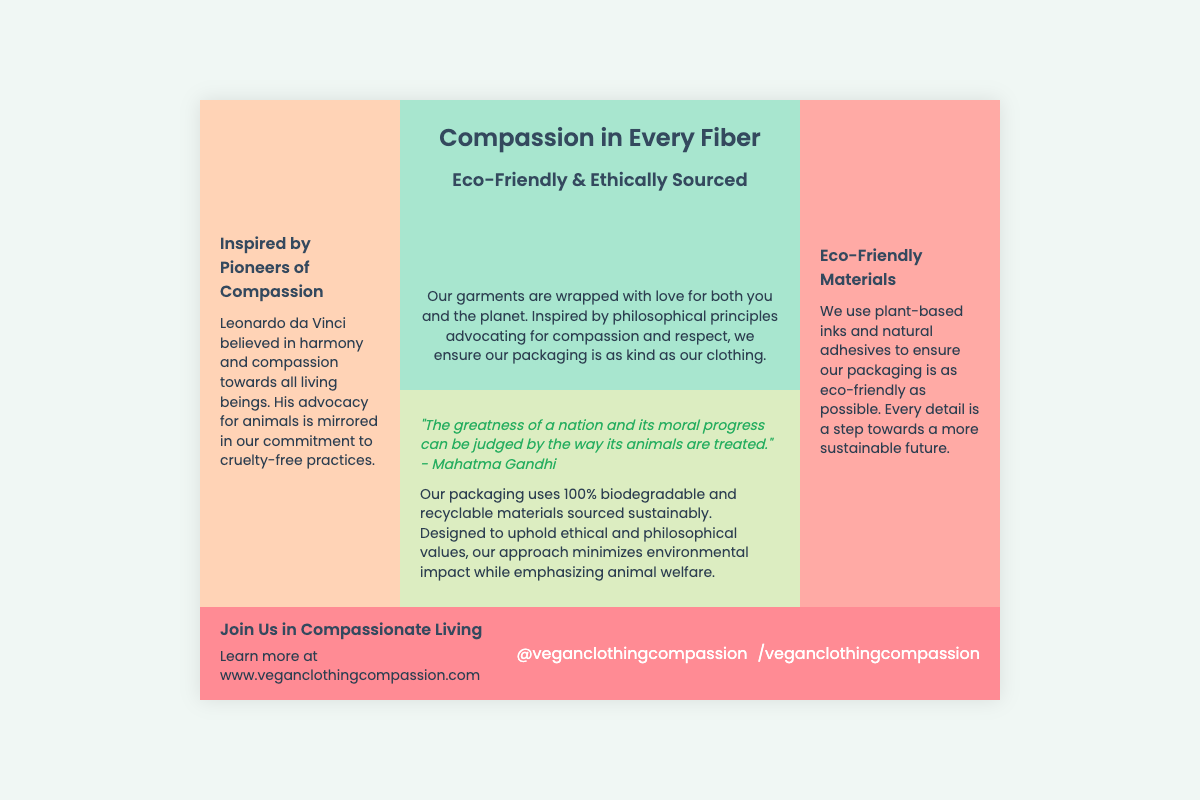What is the main theme of the packaging? The main theme of the packaging is centered around compassion and ethical sourcing, which is highlighted prominently in the title and content.
Answer: Compassion in Every Fiber Who is quoted in the back section? The back section features a quote from Mahatma Gandhi, emphasizing the importance of treating animals well.
Answer: Mahatma Gandhi What materials is the packaging made from? The document states that the packaging uses 100% biodegradable and recyclable materials that are sourced sustainably.
Answer: 100% biodegradable and recyclable materials Which historical figure is mentioned as an advocate for animal compassion? Leonardo da Vinci is referenced in the left section as a pioneer who believed in compassion towards living beings.
Answer: Leonardo da Vinci What kind of inks are used for the packaging? The document specifies that plant-based inks are used to ensure the packaging is eco-friendly.
Answer: Plant-based inks What does the bottom section encourage readers to do? The bottom section encourages readers to learn more about compassionate living and the brand online.
Answer: Join Us in Compassionate Living What color is the front section of the packaging? The front section has a light green background color, reflecting eco-friendliness and compassion themes.
Answer: Light green What does the quote in the back section suggest about societal values? The quote suggests that the treatment of animals serves as a reflection of a nation's moral progress and compassion.
Answer: Moral progress What social media handle is mentioned? The social media handle provided in the document promotes the brand on an unspecified platform.
Answer: @veganclothingcompassion 